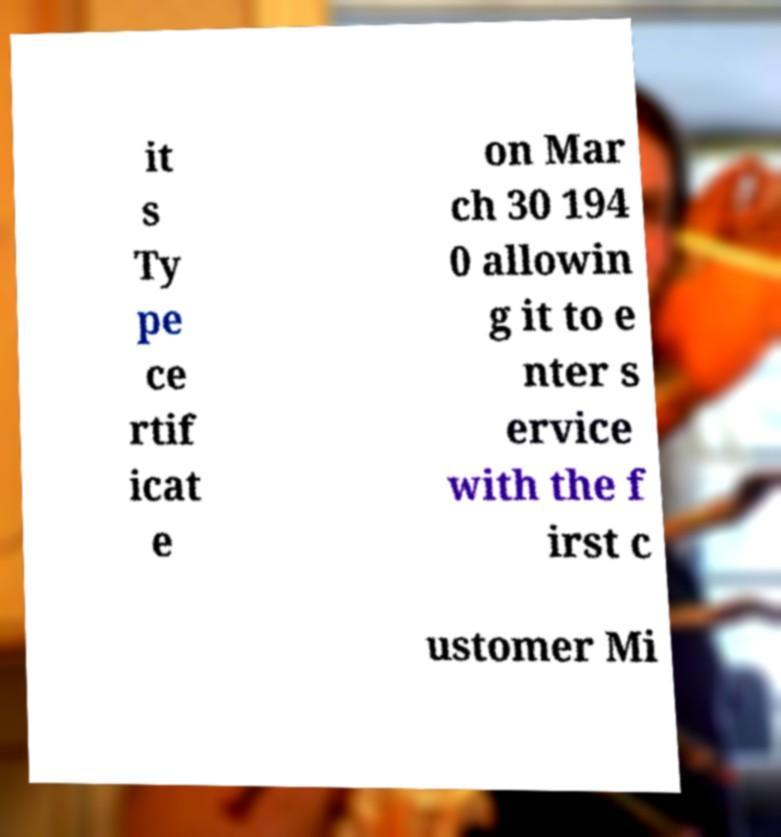Please read and relay the text visible in this image. What does it say? it s Ty pe ce rtif icat e on Mar ch 30 194 0 allowin g it to e nter s ervice with the f irst c ustomer Mi 